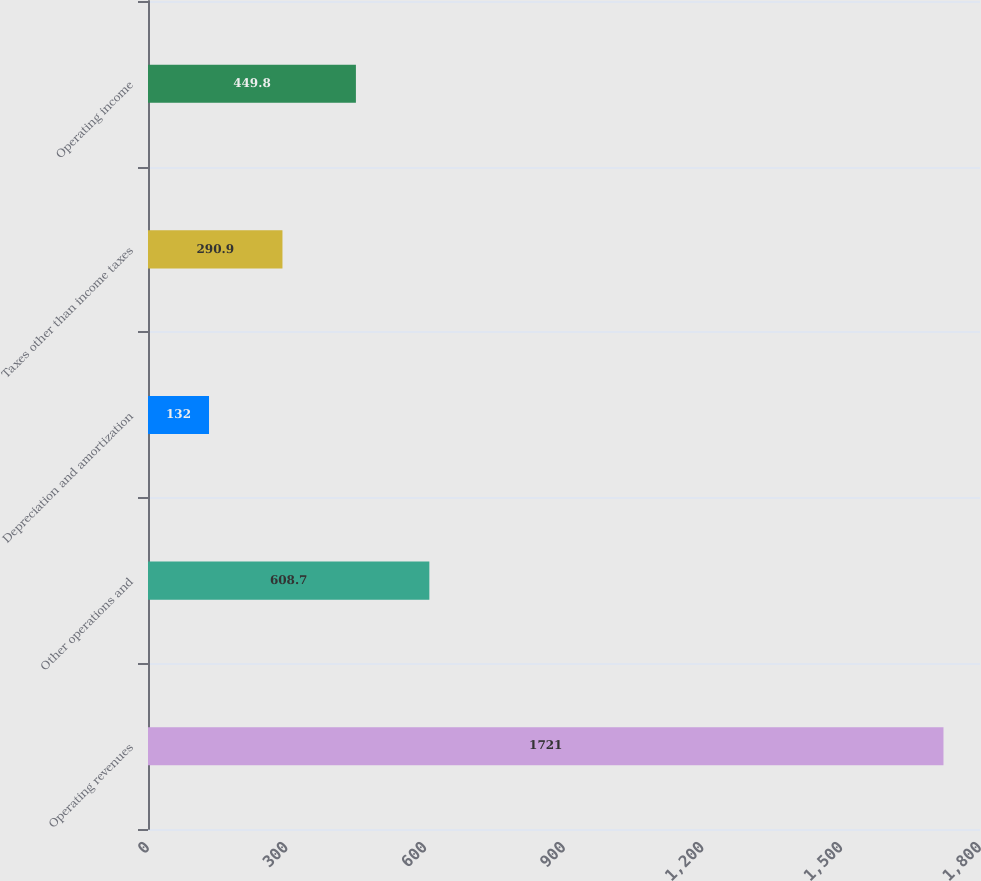Convert chart to OTSL. <chart><loc_0><loc_0><loc_500><loc_500><bar_chart><fcel>Operating revenues<fcel>Other operations and<fcel>Depreciation and amortization<fcel>Taxes other than income taxes<fcel>Operating income<nl><fcel>1721<fcel>608.7<fcel>132<fcel>290.9<fcel>449.8<nl></chart> 